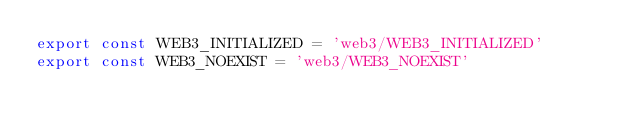Convert code to text. <code><loc_0><loc_0><loc_500><loc_500><_JavaScript_>export const WEB3_INITIALIZED = 'web3/WEB3_INITIALIZED'
export const WEB3_NOEXIST = 'web3/WEB3_NOEXIST'
</code> 